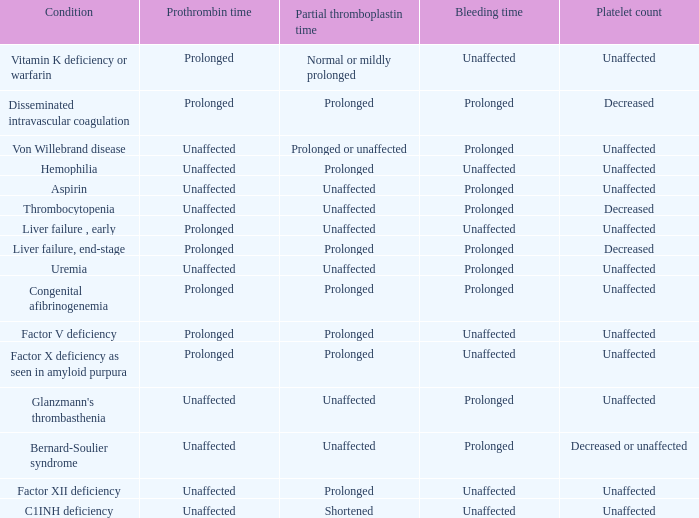Which Platelet count has a Condition of factor v deficiency? Unaffected. Could you help me parse every detail presented in this table? {'header': ['Condition', 'Prothrombin time', 'Partial thromboplastin time', 'Bleeding time', 'Platelet count'], 'rows': [['Vitamin K deficiency or warfarin', 'Prolonged', 'Normal or mildly prolonged', 'Unaffected', 'Unaffected'], ['Disseminated intravascular coagulation', 'Prolonged', 'Prolonged', 'Prolonged', 'Decreased'], ['Von Willebrand disease', 'Unaffected', 'Prolonged or unaffected', 'Prolonged', 'Unaffected'], ['Hemophilia', 'Unaffected', 'Prolonged', 'Unaffected', 'Unaffected'], ['Aspirin', 'Unaffected', 'Unaffected', 'Prolonged', 'Unaffected'], ['Thrombocytopenia', 'Unaffected', 'Unaffected', 'Prolonged', 'Decreased'], ['Liver failure , early', 'Prolonged', 'Unaffected', 'Unaffected', 'Unaffected'], ['Liver failure, end-stage', 'Prolonged', 'Prolonged', 'Prolonged', 'Decreased'], ['Uremia', 'Unaffected', 'Unaffected', 'Prolonged', 'Unaffected'], ['Congenital afibrinogenemia', 'Prolonged', 'Prolonged', 'Prolonged', 'Unaffected'], ['Factor V deficiency', 'Prolonged', 'Prolonged', 'Unaffected', 'Unaffected'], ['Factor X deficiency as seen in amyloid purpura', 'Prolonged', 'Prolonged', 'Unaffected', 'Unaffected'], ["Glanzmann's thrombasthenia", 'Unaffected', 'Unaffected', 'Prolonged', 'Unaffected'], ['Bernard-Soulier syndrome', 'Unaffected', 'Unaffected', 'Prolonged', 'Decreased or unaffected'], ['Factor XII deficiency', 'Unaffected', 'Prolonged', 'Unaffected', 'Unaffected'], ['C1INH deficiency', 'Unaffected', 'Shortened', 'Unaffected', 'Unaffected']]} 